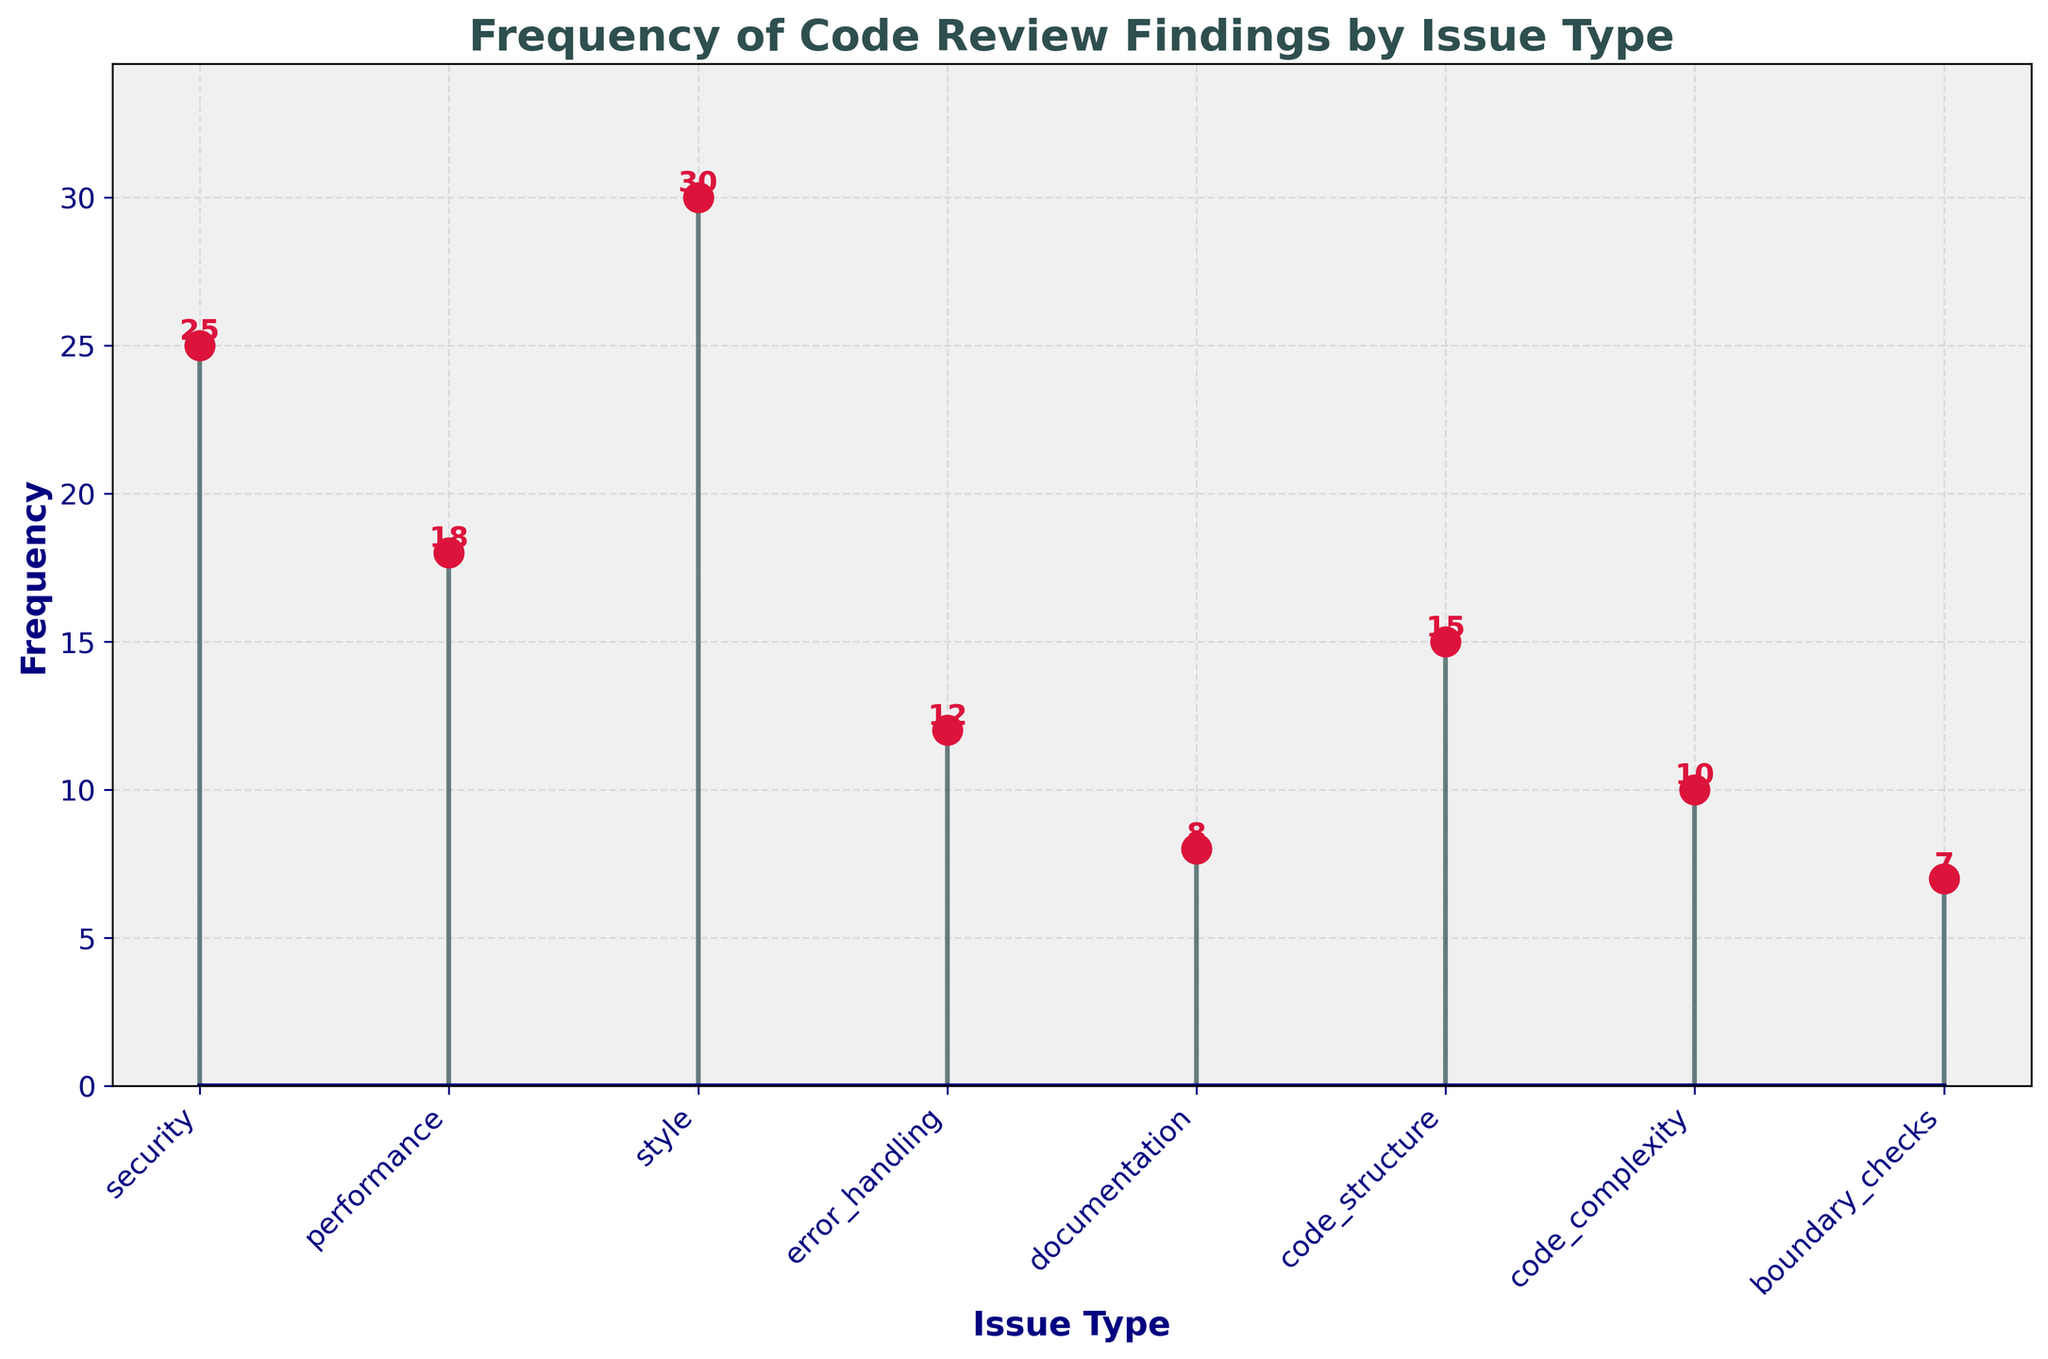What is the most frequent type of code review finding? The figure shows the highest stem is above the 'style' label on the x-axis, which has a frequency of 30.
Answer: Style What is the title of the figure? The title is clearly shown at the top of the figure. It reads 'Frequency of Code Review Findings by Issue Type'.
Answer: Frequency of Code Review Findings by Issue Type Which issue type has the lowest frequency in code review findings? The shortest stem in the figure is above the 'boundary_checks' label on the x-axis, indicating it has the lowest frequency of 7.
Answer: Boundary Checks What is the sum of the frequency of 'performance' and 'code_structure' issues? The frequency of 'performance' issues is 18 and 'code_structure' issues is 15. Summing these gives 18 + 15 = 33.
Answer: 33 How many issue types have a frequency greater than 20? From the figure, 'style' (30) and 'security' (25) have frequencies greater than 20. That makes 2 issue types.
Answer: 2 Which two issue types have the closest frequencies, and what are their values? The closest frequencies are 'performance' and 'code_structure' with values of 18 and 15 respectively. The difference is 3.
Answer: Performance and Code Structure (18 and 15) What is the combined frequency of all issues related to code quality (style, documentation, code_structure, code_complexity)? The frequencies are 'style' (30), 'documentation' (8), 'code_structure' (15), and 'code_complexity' (10). Summing these gives 30 + 8 + 15 + 10 = 63.
Answer: 63 Which issue type is the second most frequent? The figure shows 'security' issues have a frequency of 25, which is the second highest after 'style'.
Answer: Security How does the frequency of 'error_handling' compare to the frequency of 'boundary_checks'? 'Error_handling' has a frequency of 12, while 'boundary_checks' has a frequency of 7. Therefore, 'error_handling' is greater by 5.
Answer: Error Handling is greater by 5 What is the average frequency of all the issues reported? Adding all frequencies: 25 (security) + 18 (performance) + 30 (style) + 12 (error_handling) + 8 (documentation) + 15 (code_structure) + 10 (code_complexity) + 7 (boundary_checks) = 125. There are 8 issue types, so the average is 125/8 = 15.625.
Answer: 15.625 